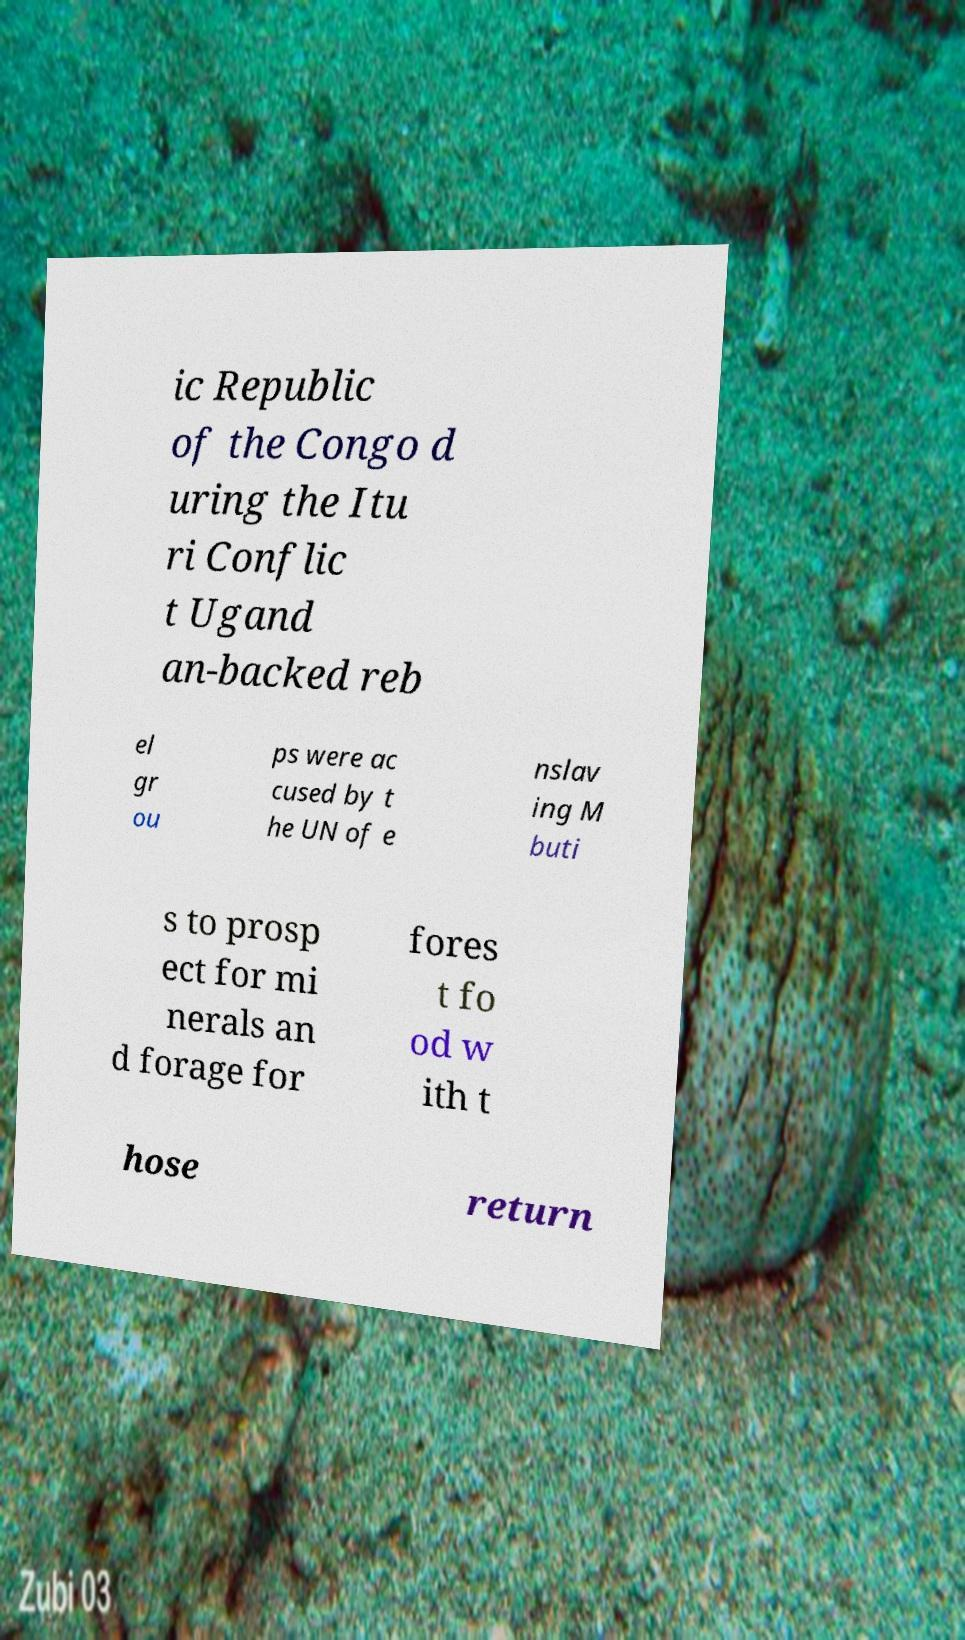Could you extract and type out the text from this image? ic Republic of the Congo d uring the Itu ri Conflic t Ugand an-backed reb el gr ou ps were ac cused by t he UN of e nslav ing M buti s to prosp ect for mi nerals an d forage for fores t fo od w ith t hose return 